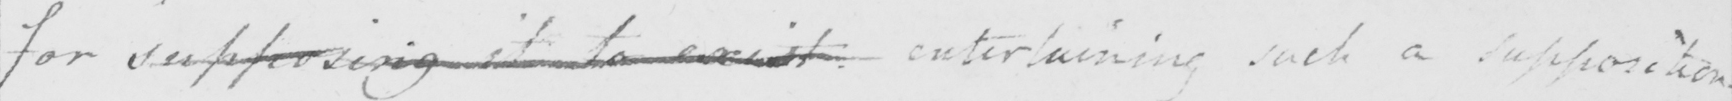Please provide the text content of this handwritten line. for supposing it to exist entertaining such a supposition . 